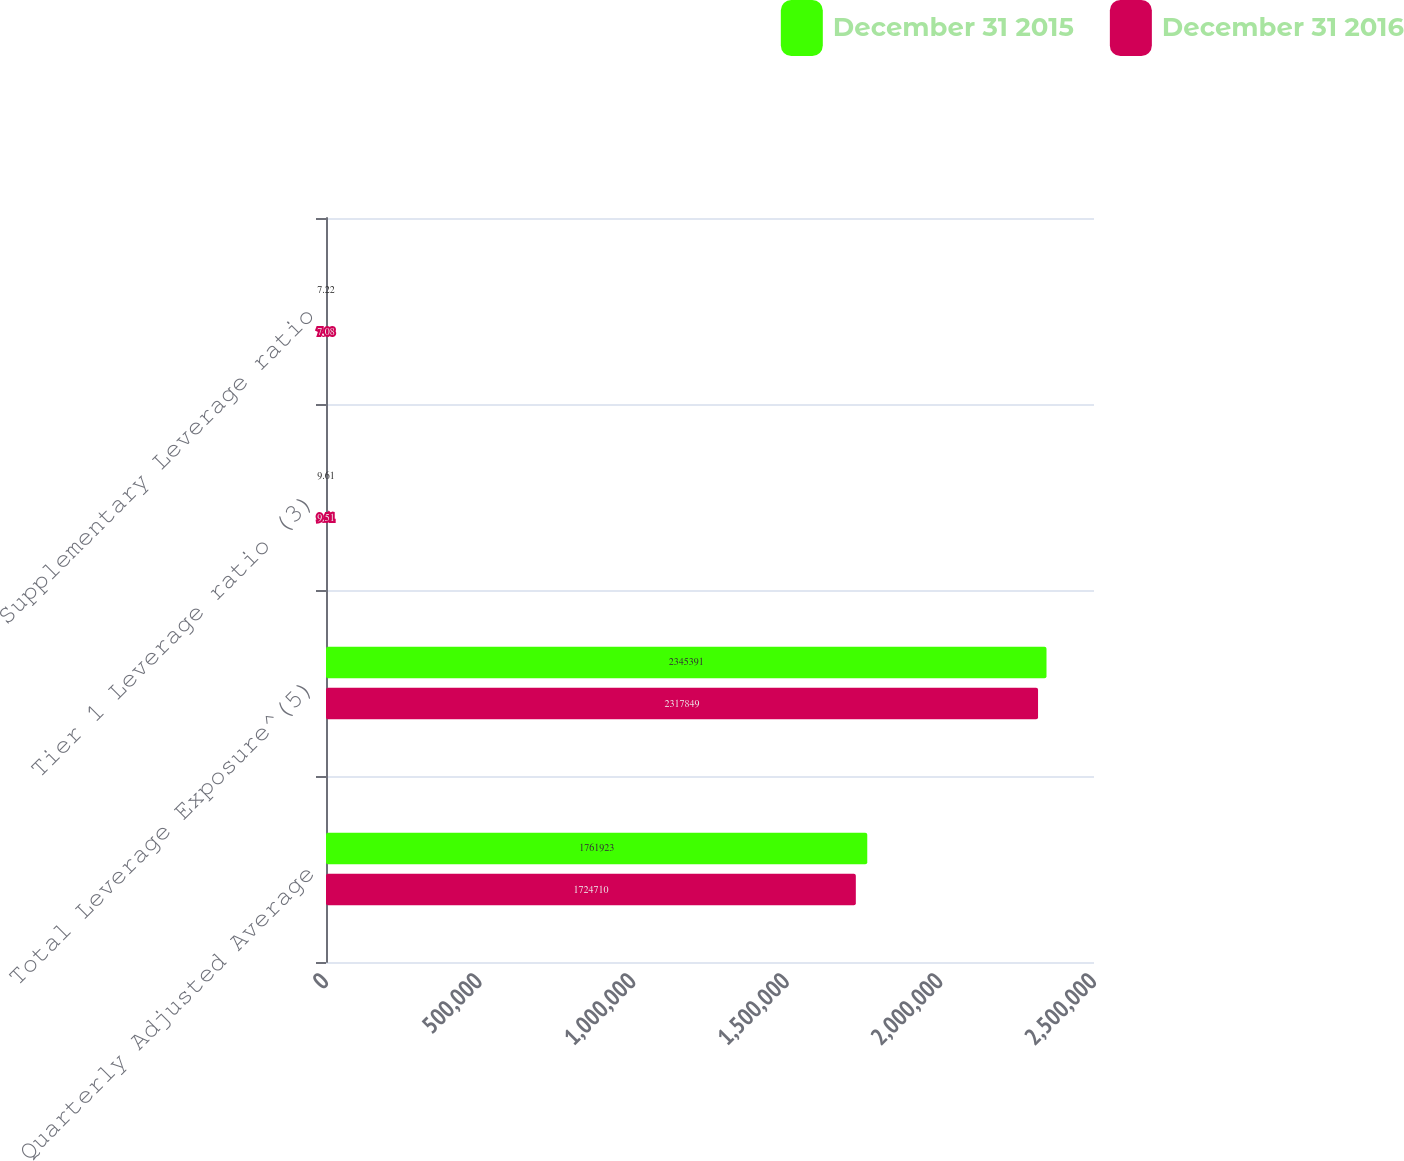Convert chart to OTSL. <chart><loc_0><loc_0><loc_500><loc_500><stacked_bar_chart><ecel><fcel>Quarterly Adjusted Average<fcel>Total Leverage Exposure^(5)<fcel>Tier 1 Leverage ratio (3)<fcel>Supplementary Leverage ratio<nl><fcel>December 31 2015<fcel>1.76192e+06<fcel>2.34539e+06<fcel>9.61<fcel>7.22<nl><fcel>December 31 2016<fcel>1.72471e+06<fcel>2.31785e+06<fcel>9.51<fcel>7.08<nl></chart> 